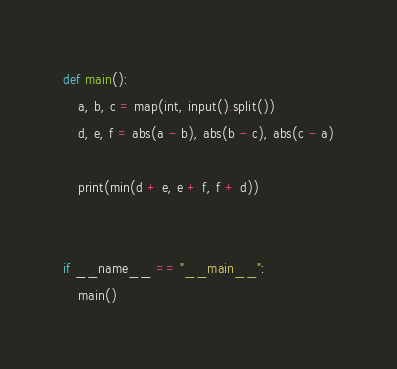Convert code to text. <code><loc_0><loc_0><loc_500><loc_500><_Python_>def main():
    a, b, c = map(int, input().split())
    d, e, f = abs(a - b), abs(b - c), abs(c - a)

    print(min(d + e, e + f, f + d))


if __name__ == "__main__":
    main()
</code> 